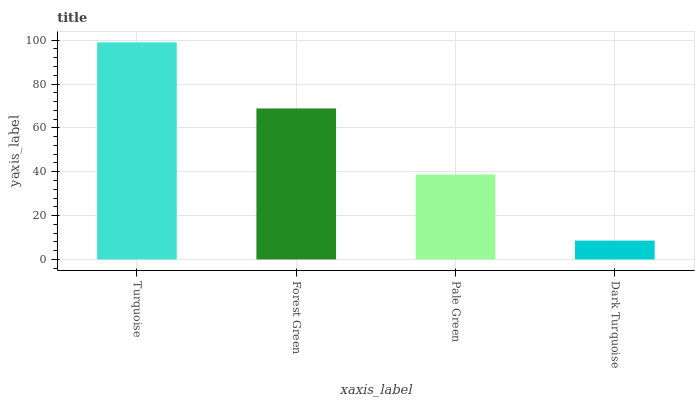Is Dark Turquoise the minimum?
Answer yes or no. Yes. Is Turquoise the maximum?
Answer yes or no. Yes. Is Forest Green the minimum?
Answer yes or no. No. Is Forest Green the maximum?
Answer yes or no. No. Is Turquoise greater than Forest Green?
Answer yes or no. Yes. Is Forest Green less than Turquoise?
Answer yes or no. Yes. Is Forest Green greater than Turquoise?
Answer yes or no. No. Is Turquoise less than Forest Green?
Answer yes or no. No. Is Forest Green the high median?
Answer yes or no. Yes. Is Pale Green the low median?
Answer yes or no. Yes. Is Dark Turquoise the high median?
Answer yes or no. No. Is Turquoise the low median?
Answer yes or no. No. 